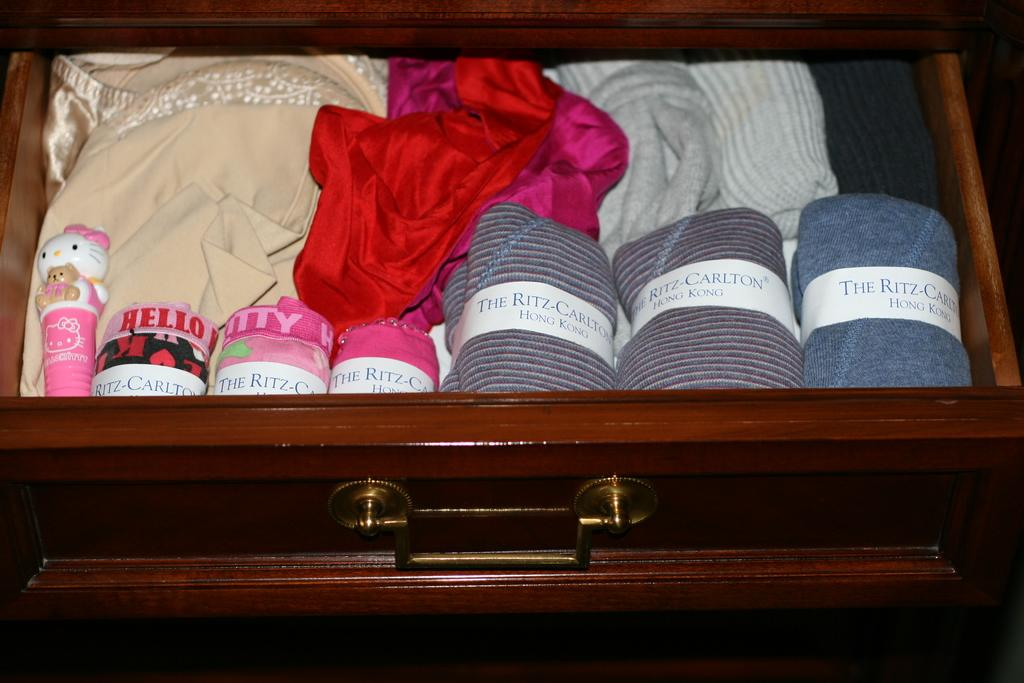Provide a one-sentence caption for the provided image. Dresser that contains The Ritz Carlton in Hong Kong. 